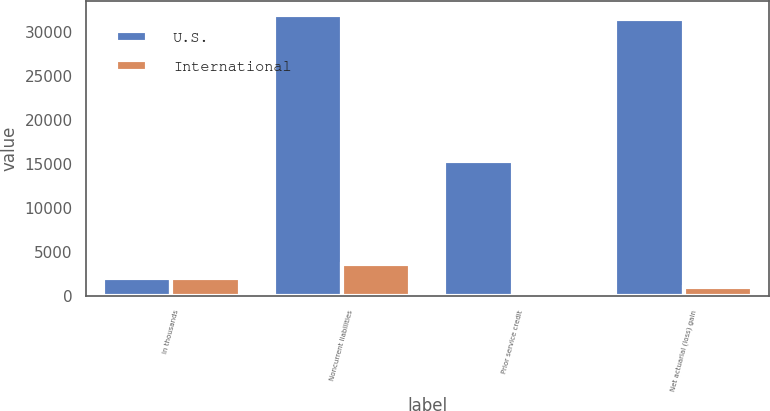<chart> <loc_0><loc_0><loc_500><loc_500><stacked_bar_chart><ecel><fcel>In thousands<fcel>Noncurrent liabilities<fcel>Prior service credit<fcel>Net actuarial (loss) gain<nl><fcel>U.S.<fcel>2011<fcel>31909<fcel>15271<fcel>31380<nl><fcel>International<fcel>2011<fcel>3678<fcel>495<fcel>1049<nl></chart> 